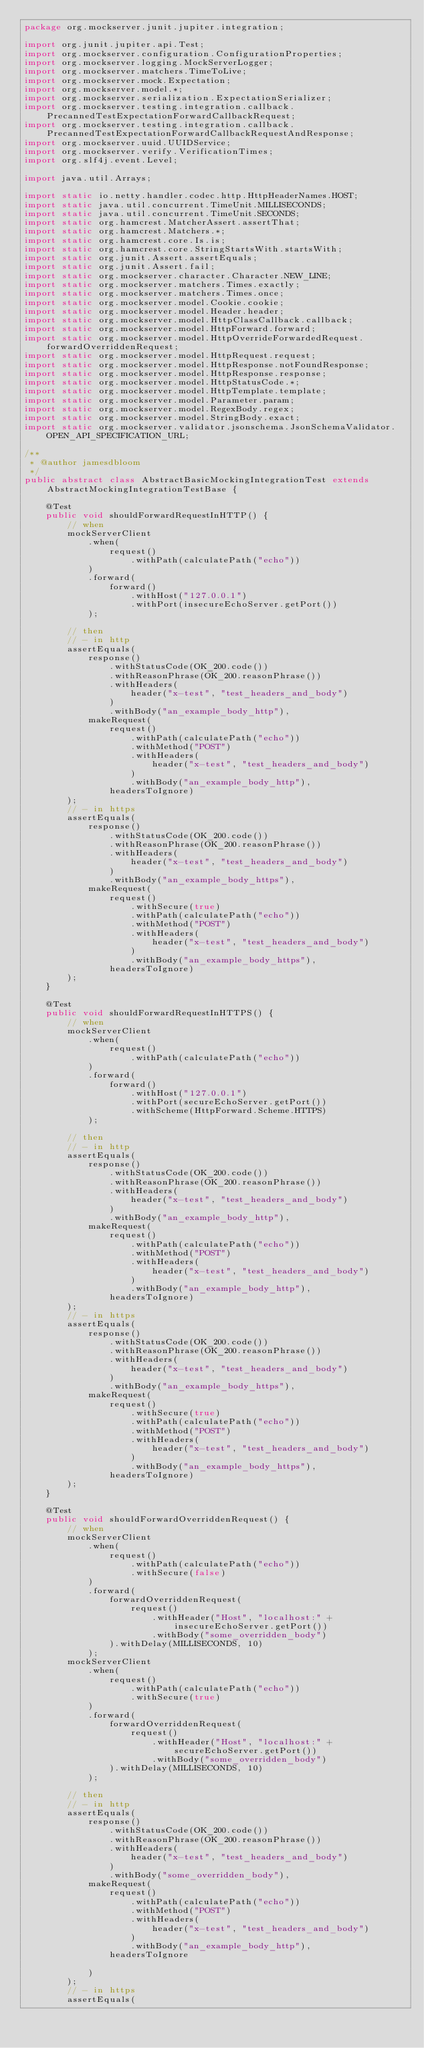<code> <loc_0><loc_0><loc_500><loc_500><_Java_>package org.mockserver.junit.jupiter.integration;

import org.junit.jupiter.api.Test;
import org.mockserver.configuration.ConfigurationProperties;
import org.mockserver.logging.MockServerLogger;
import org.mockserver.matchers.TimeToLive;
import org.mockserver.mock.Expectation;
import org.mockserver.model.*;
import org.mockserver.serialization.ExpectationSerializer;
import org.mockserver.testing.integration.callback.PrecannedTestExpectationForwardCallbackRequest;
import org.mockserver.testing.integration.callback.PrecannedTestExpectationForwardCallbackRequestAndResponse;
import org.mockserver.uuid.UUIDService;
import org.mockserver.verify.VerificationTimes;
import org.slf4j.event.Level;

import java.util.Arrays;

import static io.netty.handler.codec.http.HttpHeaderNames.HOST;
import static java.util.concurrent.TimeUnit.MILLISECONDS;
import static java.util.concurrent.TimeUnit.SECONDS;
import static org.hamcrest.MatcherAssert.assertThat;
import static org.hamcrest.Matchers.*;
import static org.hamcrest.core.Is.is;
import static org.hamcrest.core.StringStartsWith.startsWith;
import static org.junit.Assert.assertEquals;
import static org.junit.Assert.fail;
import static org.mockserver.character.Character.NEW_LINE;
import static org.mockserver.matchers.Times.exactly;
import static org.mockserver.matchers.Times.once;
import static org.mockserver.model.Cookie.cookie;
import static org.mockserver.model.Header.header;
import static org.mockserver.model.HttpClassCallback.callback;
import static org.mockserver.model.HttpForward.forward;
import static org.mockserver.model.HttpOverrideForwardedRequest.forwardOverriddenRequest;
import static org.mockserver.model.HttpRequest.request;
import static org.mockserver.model.HttpResponse.notFoundResponse;
import static org.mockserver.model.HttpResponse.response;
import static org.mockserver.model.HttpStatusCode.*;
import static org.mockserver.model.HttpTemplate.template;
import static org.mockserver.model.Parameter.param;
import static org.mockserver.model.RegexBody.regex;
import static org.mockserver.model.StringBody.exact;
import static org.mockserver.validator.jsonschema.JsonSchemaValidator.OPEN_API_SPECIFICATION_URL;

/**
 * @author jamesdbloom
 */
public abstract class AbstractBasicMockingIntegrationTest extends AbstractMockingIntegrationTestBase {

    @Test
    public void shouldForwardRequestInHTTP() {
        // when
        mockServerClient
            .when(
                request()
                    .withPath(calculatePath("echo"))
            )
            .forward(
                forward()
                    .withHost("127.0.0.1")
                    .withPort(insecureEchoServer.getPort())
            );

        // then
        // - in http
        assertEquals(
            response()
                .withStatusCode(OK_200.code())
                .withReasonPhrase(OK_200.reasonPhrase())
                .withHeaders(
                    header("x-test", "test_headers_and_body")
                )
                .withBody("an_example_body_http"),
            makeRequest(
                request()
                    .withPath(calculatePath("echo"))
                    .withMethod("POST")
                    .withHeaders(
                        header("x-test", "test_headers_and_body")
                    )
                    .withBody("an_example_body_http"),
                headersToIgnore)
        );
        // - in https
        assertEquals(
            response()
                .withStatusCode(OK_200.code())
                .withReasonPhrase(OK_200.reasonPhrase())
                .withHeaders(
                    header("x-test", "test_headers_and_body")
                )
                .withBody("an_example_body_https"),
            makeRequest(
                request()
                    .withSecure(true)
                    .withPath(calculatePath("echo"))
                    .withMethod("POST")
                    .withHeaders(
                        header("x-test", "test_headers_and_body")
                    )
                    .withBody("an_example_body_https"),
                headersToIgnore)
        );
    }

    @Test
    public void shouldForwardRequestInHTTPS() {
        // when
        mockServerClient
            .when(
                request()
                    .withPath(calculatePath("echo"))
            )
            .forward(
                forward()
                    .withHost("127.0.0.1")
                    .withPort(secureEchoServer.getPort())
                    .withScheme(HttpForward.Scheme.HTTPS)
            );

        // then
        // - in http
        assertEquals(
            response()
                .withStatusCode(OK_200.code())
                .withReasonPhrase(OK_200.reasonPhrase())
                .withHeaders(
                    header("x-test", "test_headers_and_body")
                )
                .withBody("an_example_body_http"),
            makeRequest(
                request()
                    .withPath(calculatePath("echo"))
                    .withMethod("POST")
                    .withHeaders(
                        header("x-test", "test_headers_and_body")
                    )
                    .withBody("an_example_body_http"),
                headersToIgnore)
        );
        // - in https
        assertEquals(
            response()
                .withStatusCode(OK_200.code())
                .withReasonPhrase(OK_200.reasonPhrase())
                .withHeaders(
                    header("x-test", "test_headers_and_body")
                )
                .withBody("an_example_body_https"),
            makeRequest(
                request()
                    .withSecure(true)
                    .withPath(calculatePath("echo"))
                    .withMethod("POST")
                    .withHeaders(
                        header("x-test", "test_headers_and_body")
                    )
                    .withBody("an_example_body_https"),
                headersToIgnore)
        );
    }

    @Test
    public void shouldForwardOverriddenRequest() {
        // when
        mockServerClient
            .when(
                request()
                    .withPath(calculatePath("echo"))
                    .withSecure(false)
            )
            .forward(
                forwardOverriddenRequest(
                    request()
                        .withHeader("Host", "localhost:" + insecureEchoServer.getPort())
                        .withBody("some_overridden_body")
                ).withDelay(MILLISECONDS, 10)
            );
        mockServerClient
            .when(
                request()
                    .withPath(calculatePath("echo"))
                    .withSecure(true)
            )
            .forward(
                forwardOverriddenRequest(
                    request()
                        .withHeader("Host", "localhost:" + secureEchoServer.getPort())
                        .withBody("some_overridden_body")
                ).withDelay(MILLISECONDS, 10)
            );

        // then
        // - in http
        assertEquals(
            response()
                .withStatusCode(OK_200.code())
                .withReasonPhrase(OK_200.reasonPhrase())
                .withHeaders(
                    header("x-test", "test_headers_and_body")
                )
                .withBody("some_overridden_body"),
            makeRequest(
                request()
                    .withPath(calculatePath("echo"))
                    .withMethod("POST")
                    .withHeaders(
                        header("x-test", "test_headers_and_body")
                    )
                    .withBody("an_example_body_http"),
                headersToIgnore

            )
        );
        // - in https
        assertEquals(</code> 